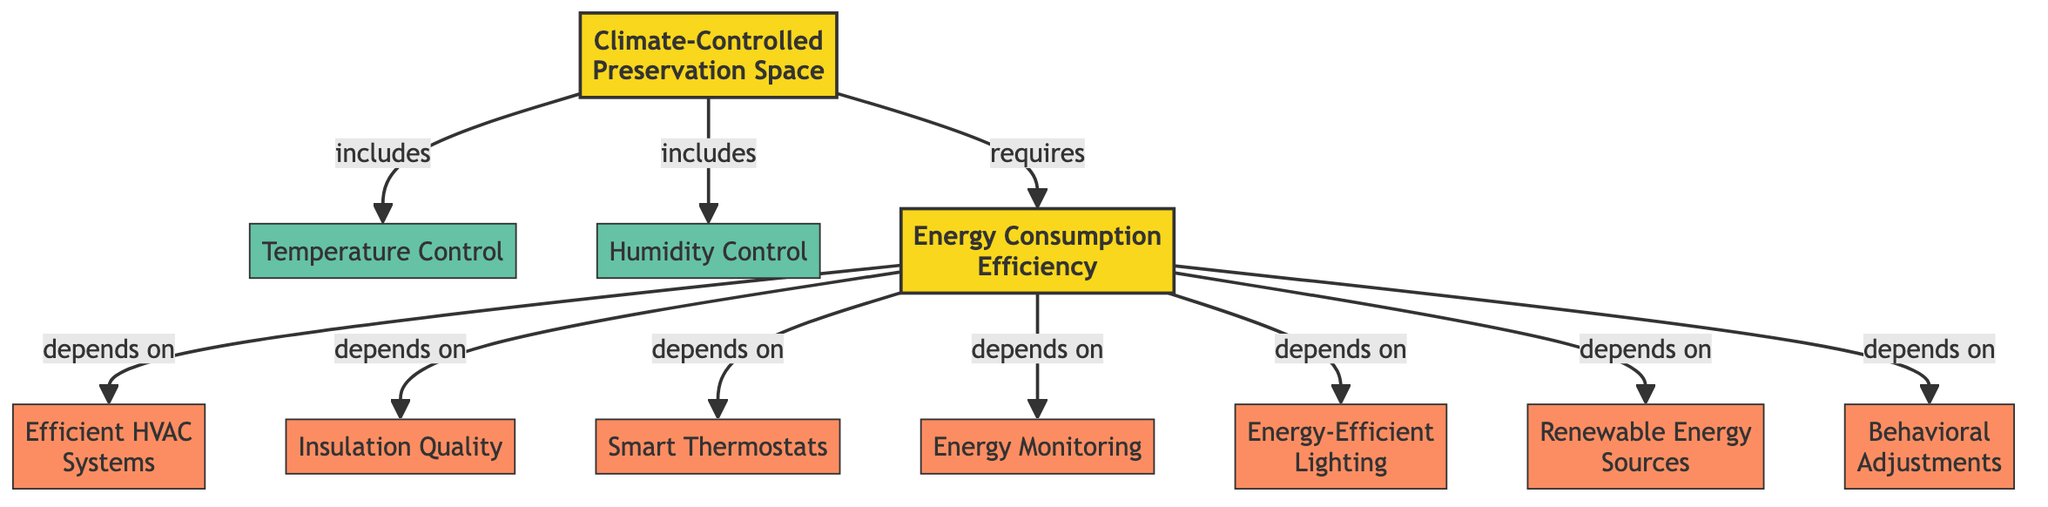What is the main subject of the graph? The main subject is represented by the node labeled "Climate-Controlled Preservation Space." It is the central topic around which all other nodes are structured.
Answer: Climate-Controlled Preservation Space How many edges are present in the diagram? By counting the lines that connect nodes, there are a total of 10 edges present in the diagram.
Answer: 10 Which nodes are included in the "Climate-Controlled Preservation Space"? The edges show that "Temperature Control" and "Humidity Control" are both directly connected to the "Climate-Controlled Preservation Space," indicating they are included.
Answer: Temperature Control, Humidity Control What does "Energy Consumption Efficiency" depend on? "Energy Consumption Efficiency" is shown to depend on several nodes: "Efficient HVAC Systems," "Insulation Quality," "Smart Thermostats," "Energy Monitoring," "Energy-Efficient Lighting," "Renewable Energy Sources," and "Behavioral Adjustments."
Answer: Efficient HVAC Systems, Insulation Quality, Smart Thermostats, Energy Monitoring, Energy-Efficient Lighting, Renewable Energy Sources, Behavioral Adjustments How many subfactors contribute to "Energy Consumption Efficiency"? The diagram indicates that there are 7 subfactors connected to "Energy Consumption Efficiency," as identified by the nodes that depend on it.
Answer: 7 Which subfactor is associated with improving HVAC systems? The subfactor labeled "Efficient HVAC Systems" is specifically associated with the improvement of HVAC systems, as shown by its direct dependence on "Energy Consumption Efficiency."
Answer: Efficient HVAC Systems What is the relationship between "Energy Monitoring" and "Energy Consumption Efficiency"? "Energy Monitoring" is directly connected to "Energy Consumption Efficiency" with a "depends on" relationship, indicating it plays a crucial role in efficiency measures.
Answer: depends on Which two factors are required for efficient energy use in preservation spaces? The two critical factors indicated in the graph for efficient energy use are "Temperature Control" and "Humidity Control," both of which are essential for maintaining conditions in preservation spaces.
Answer: Temperature Control, Humidity Control What type of systems can enhance energy use in preservation spaces? The graph highlights that the incorporation of "Energy-Efficient Lighting" systems can notably enhance energy usage efficiency within preservation spaces.
Answer: Energy-Efficient Lighting 